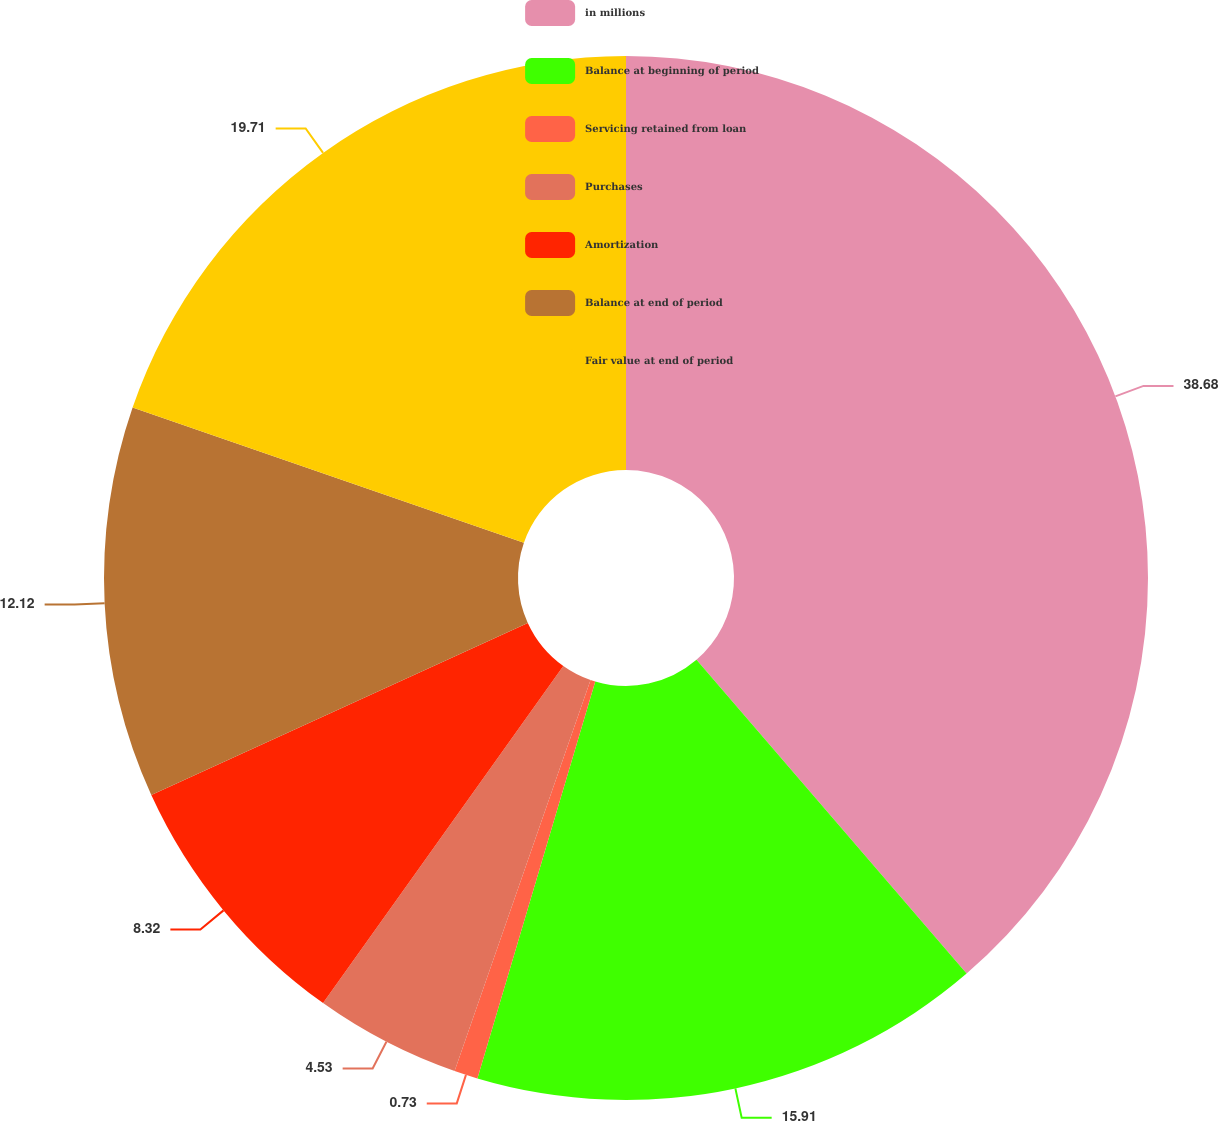<chart> <loc_0><loc_0><loc_500><loc_500><pie_chart><fcel>in millions<fcel>Balance at beginning of period<fcel>Servicing retained from loan<fcel>Purchases<fcel>Amortization<fcel>Balance at end of period<fcel>Fair value at end of period<nl><fcel>38.69%<fcel>15.91%<fcel>0.73%<fcel>4.53%<fcel>8.32%<fcel>12.12%<fcel>19.71%<nl></chart> 